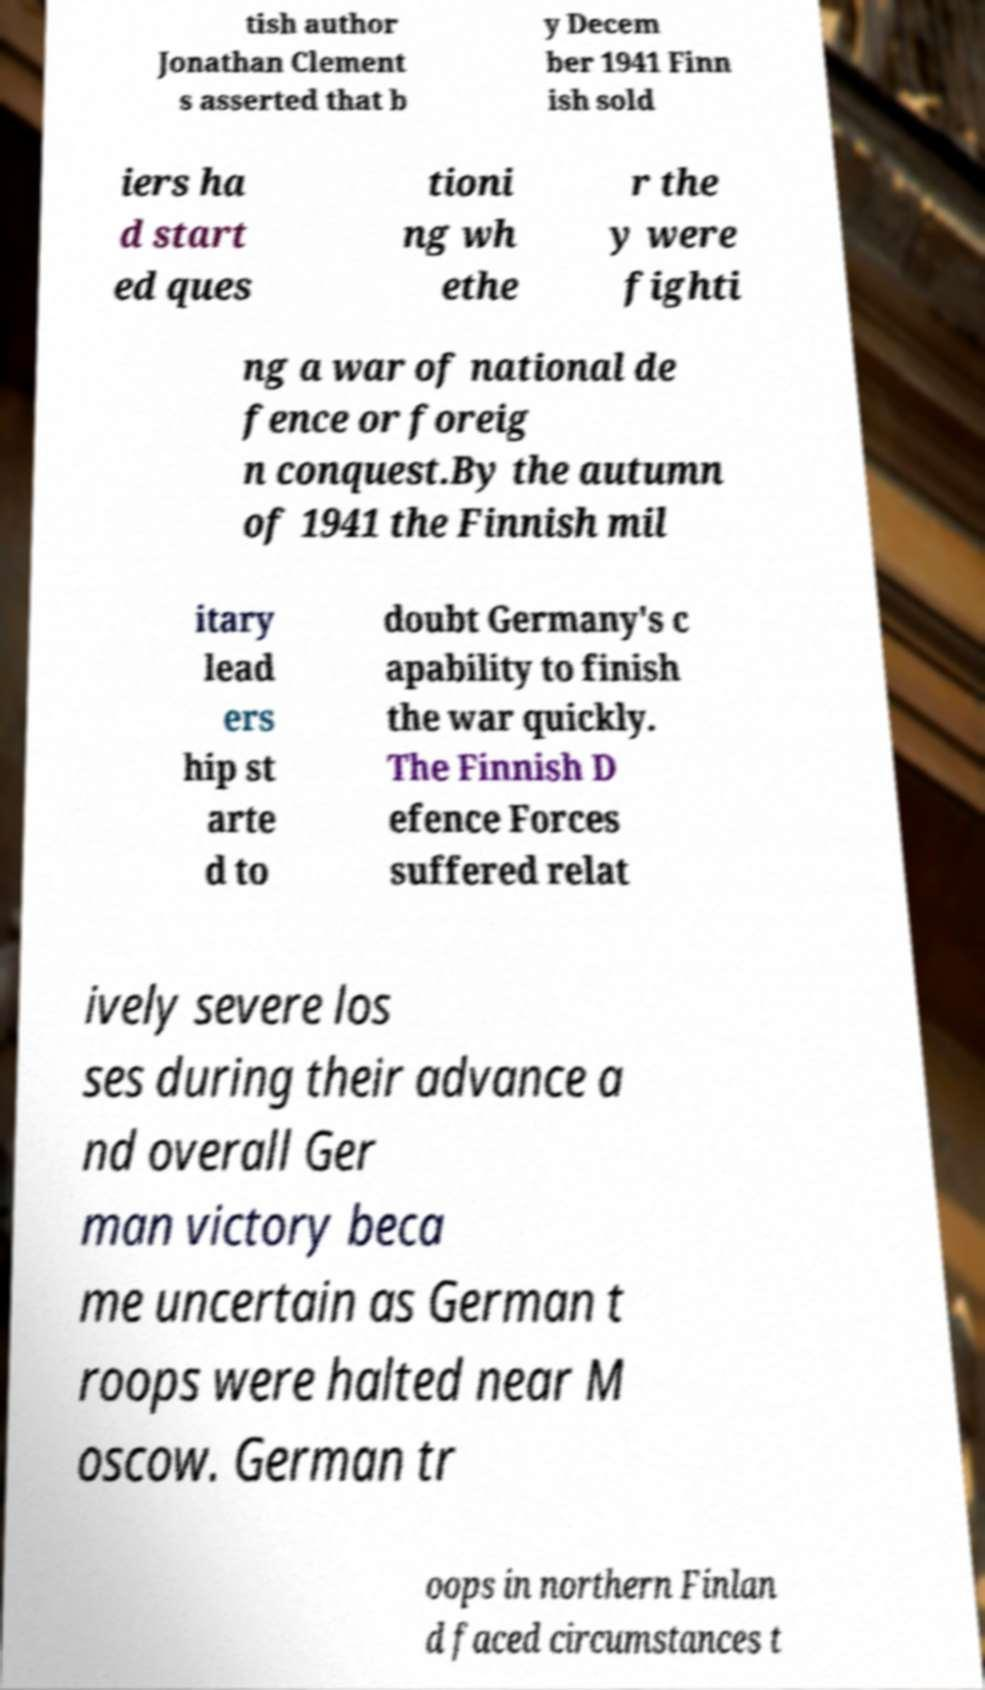For documentation purposes, I need the text within this image transcribed. Could you provide that? tish author Jonathan Clement s asserted that b y Decem ber 1941 Finn ish sold iers ha d start ed ques tioni ng wh ethe r the y were fighti ng a war of national de fence or foreig n conquest.By the autumn of 1941 the Finnish mil itary lead ers hip st arte d to doubt Germany's c apability to finish the war quickly. The Finnish D efence Forces suffered relat ively severe los ses during their advance a nd overall Ger man victory beca me uncertain as German t roops were halted near M oscow. German tr oops in northern Finlan d faced circumstances t 